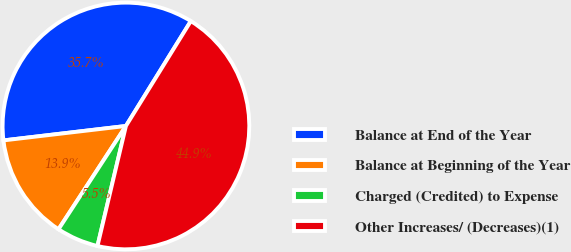Convert chart. <chart><loc_0><loc_0><loc_500><loc_500><pie_chart><fcel>Balance at End of the Year<fcel>Balance at Beginning of the Year<fcel>Charged (Credited) to Expense<fcel>Other Increases/ (Decreases)(1)<nl><fcel>35.69%<fcel>13.93%<fcel>5.5%<fcel>44.89%<nl></chart> 